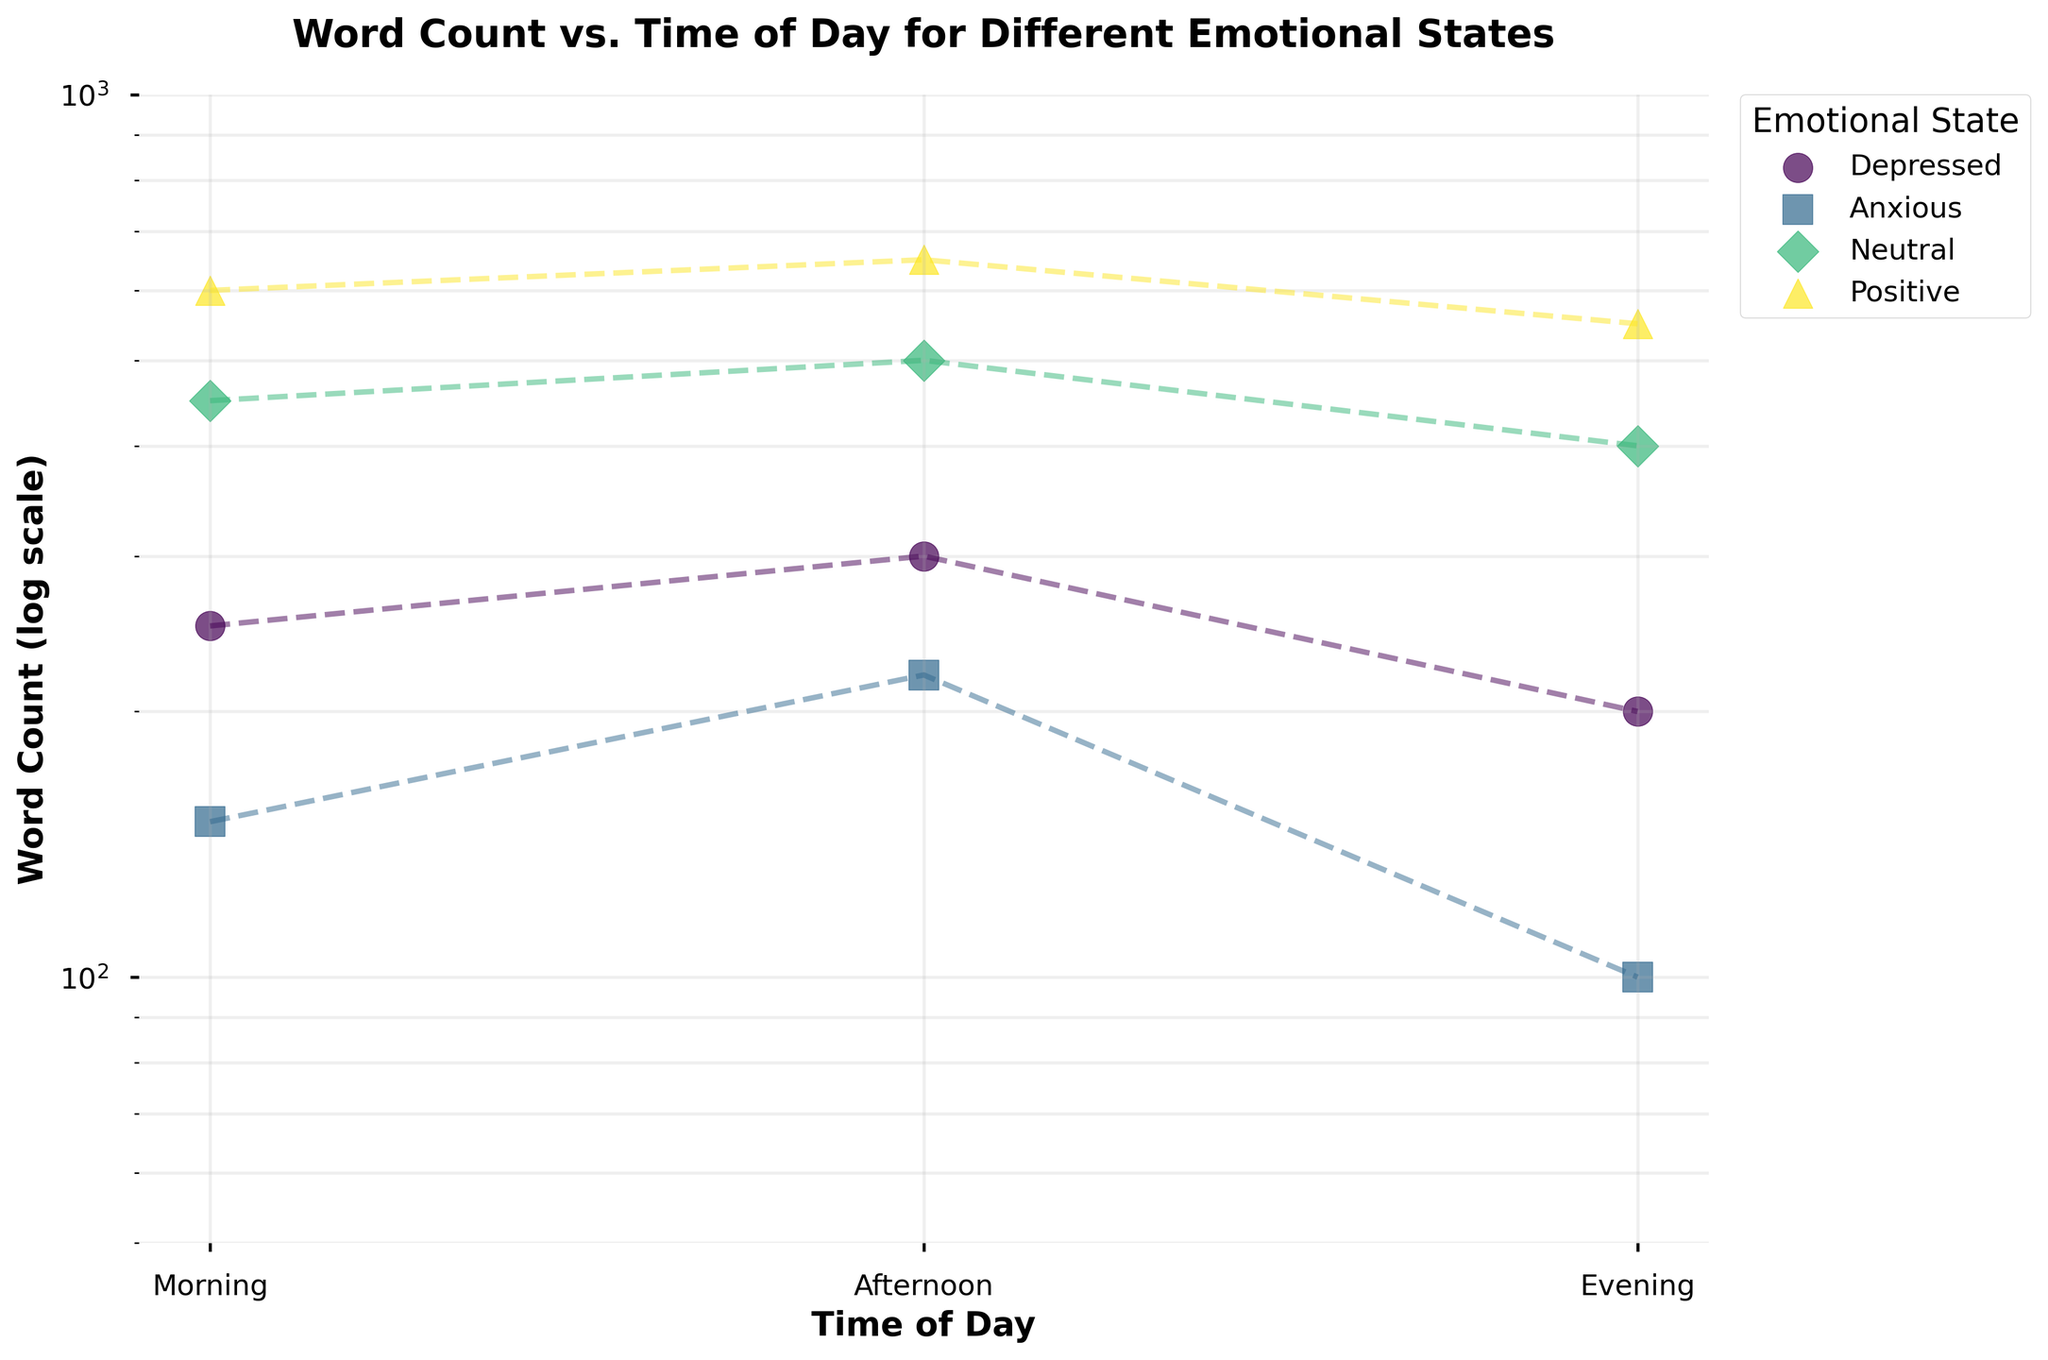What's the title of the plot? The title is displayed at the top of the plot and describes the overall content.
Answer: Word Count vs. Time of Day for Different Emotional States What is the range of the y-axis? The y-axis, which is on a log scale, ranges from 50 to 1000 according to the axis limits set in the plot.
Answer: 50 to 1000 Which time of day has the highest word count when feeling positive? By examining the 'Positive' emotional state points, the highest word count appears at 'Afternoon' with a count of 650.
Answer: Afternoon How does the word count in the evening compare between the 'Depressed' and 'Positive' emotional states? The 'Depressed' evening word count is 200, whereas the 'Positive' evening word count is 550.
Answer: The 'Positive' evening word count is higher What's the difference in word count during the afternoon between the 'Anxious' and 'Neutral' emotional states? The word count for 'Anxious' in the afternoon is 220 and for 'Neutral' is 500. The difference is calculated as 500 - 220 = 280.
Answer: 280 Which emotional state has the smallest range of word counts throughout the day? The ranges are: Depressed (100), Anxious (120), Neutral (100), Positive (100). The range for each state can be identified by subtracting the smallest word count from the largest for each state. The smallest range is 100, and it is the same for Depressed, Neutral, and Positive states.
Answer: Depressed, Neutral, and Positive What is the word count trend for the 'Neutral' emotional state from morning to evening? For the 'Neutral' emotional state, the word count is: Morning (450), Afternoon (500), Evening (400). The counts increase from morning to afternoon then decrease in the evening.
Answer: Increase then decrease How much higher is the word count in the afternoon for a 'Positive' state compared to an 'Anxious' state? The word count for 'Positive' in the afternoon is 650, while for 'Anxious' it is 220. The difference is calculated as 650 - 220.
Answer: 430 